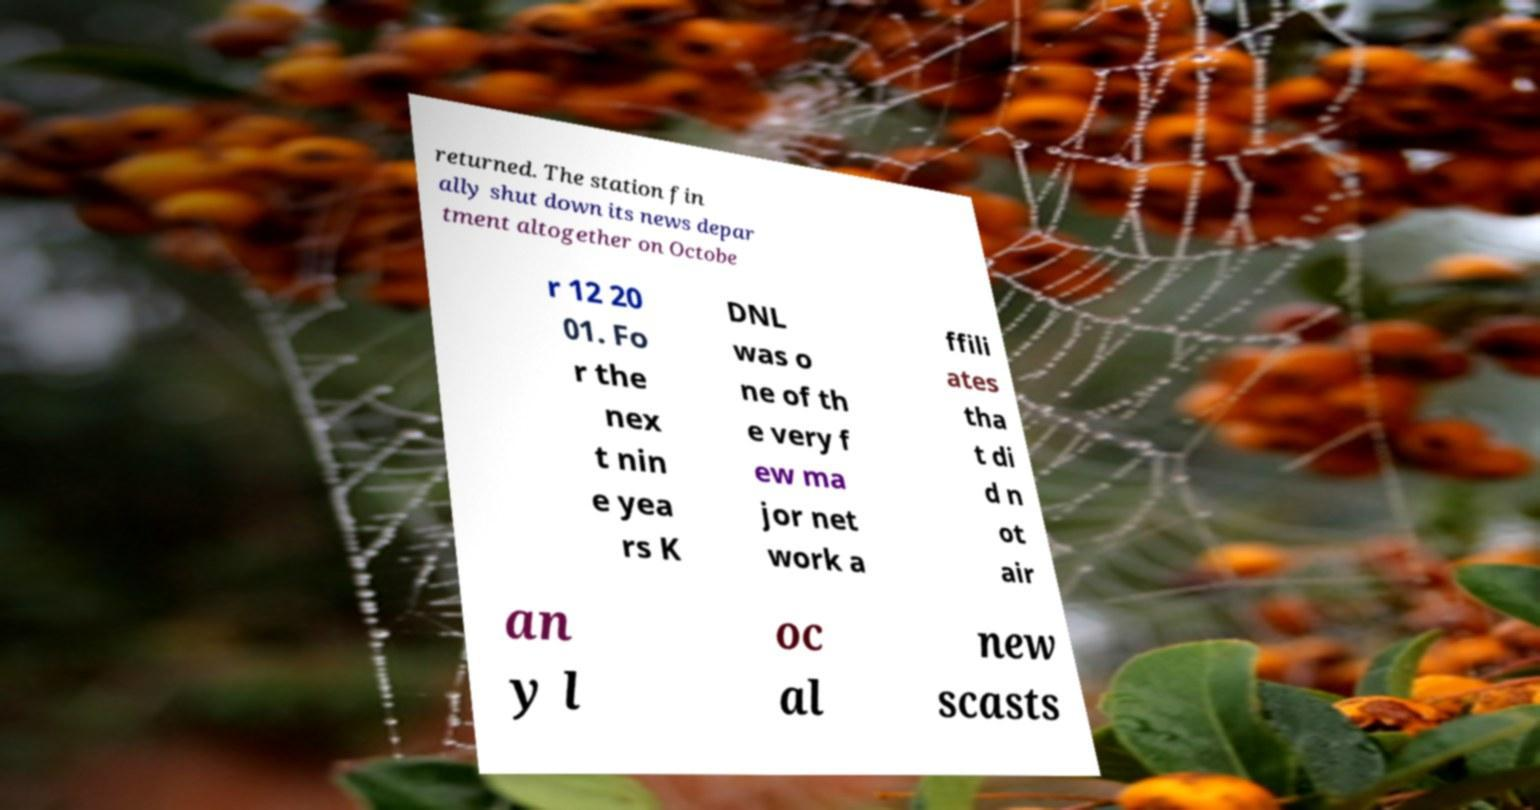Can you accurately transcribe the text from the provided image for me? returned. The station fin ally shut down its news depar tment altogether on Octobe r 12 20 01. Fo r the nex t nin e yea rs K DNL was o ne of th e very f ew ma jor net work a ffili ates tha t di d n ot air an y l oc al new scasts 